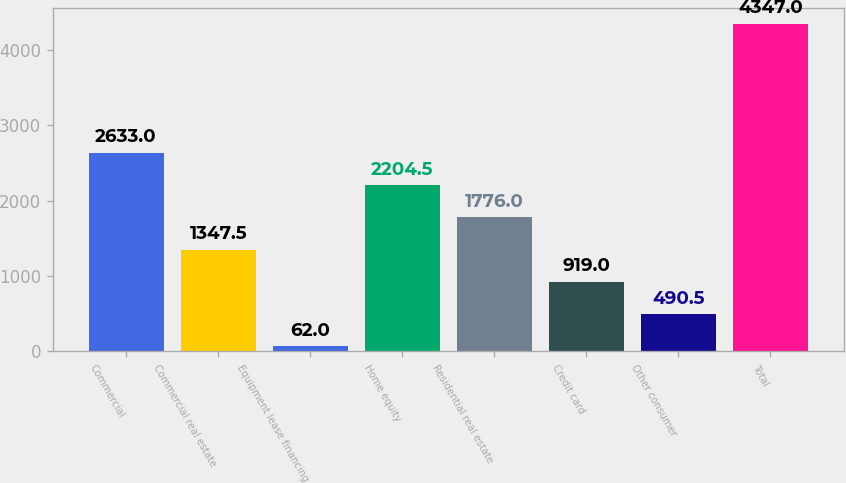Convert chart to OTSL. <chart><loc_0><loc_0><loc_500><loc_500><bar_chart><fcel>Commercial<fcel>Commercial real estate<fcel>Equipment lease financing<fcel>Home equity<fcel>Residential real estate<fcel>Credit card<fcel>Other consumer<fcel>Total<nl><fcel>2633<fcel>1347.5<fcel>62<fcel>2204.5<fcel>1776<fcel>919<fcel>490.5<fcel>4347<nl></chart> 